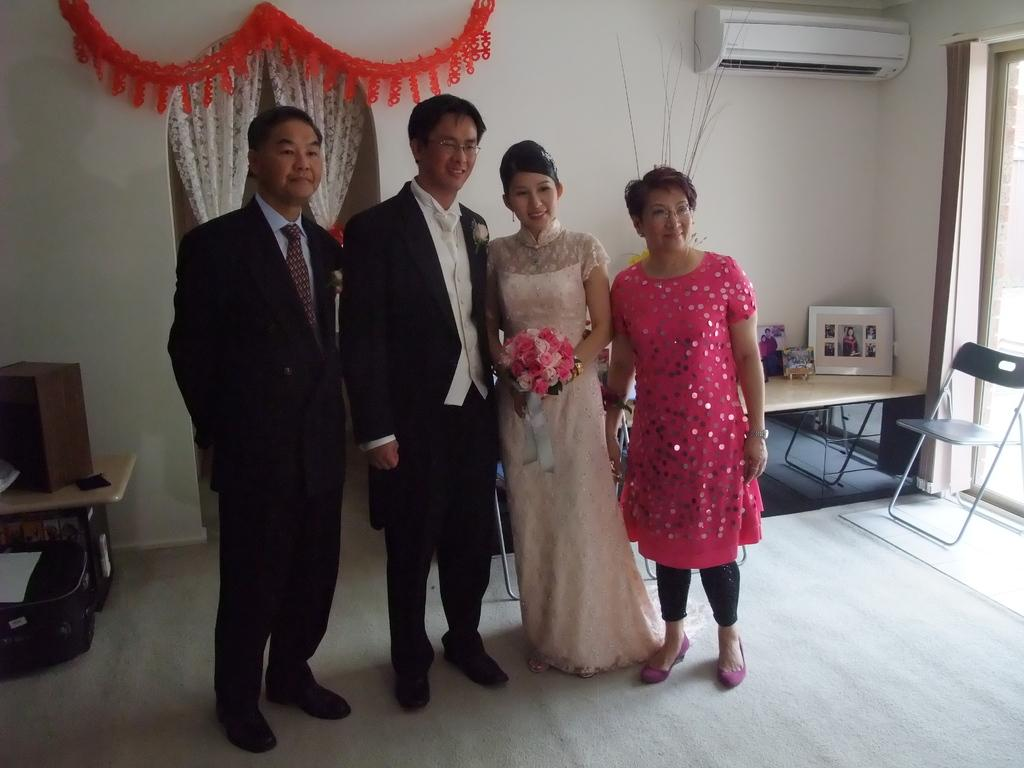What can be seen in the foreground of the image? There are people standing in the foreground of the image. What is visible in the background of the image? There is a window, curtains, a chair, and other objects in the background of the image. Can you describe the window in the background? The window is in the background of the image, and it is likely a source of natural light. What type of objects are present in the background of the image? The other objects in the background of the image could include furniture, decorations, or other items. Can you see the river flowing through the image? There is no river present in the image. What emotion can be seen on the faces of the people in the image? The provided facts do not mention any emotions or facial expressions of the people in the image. 